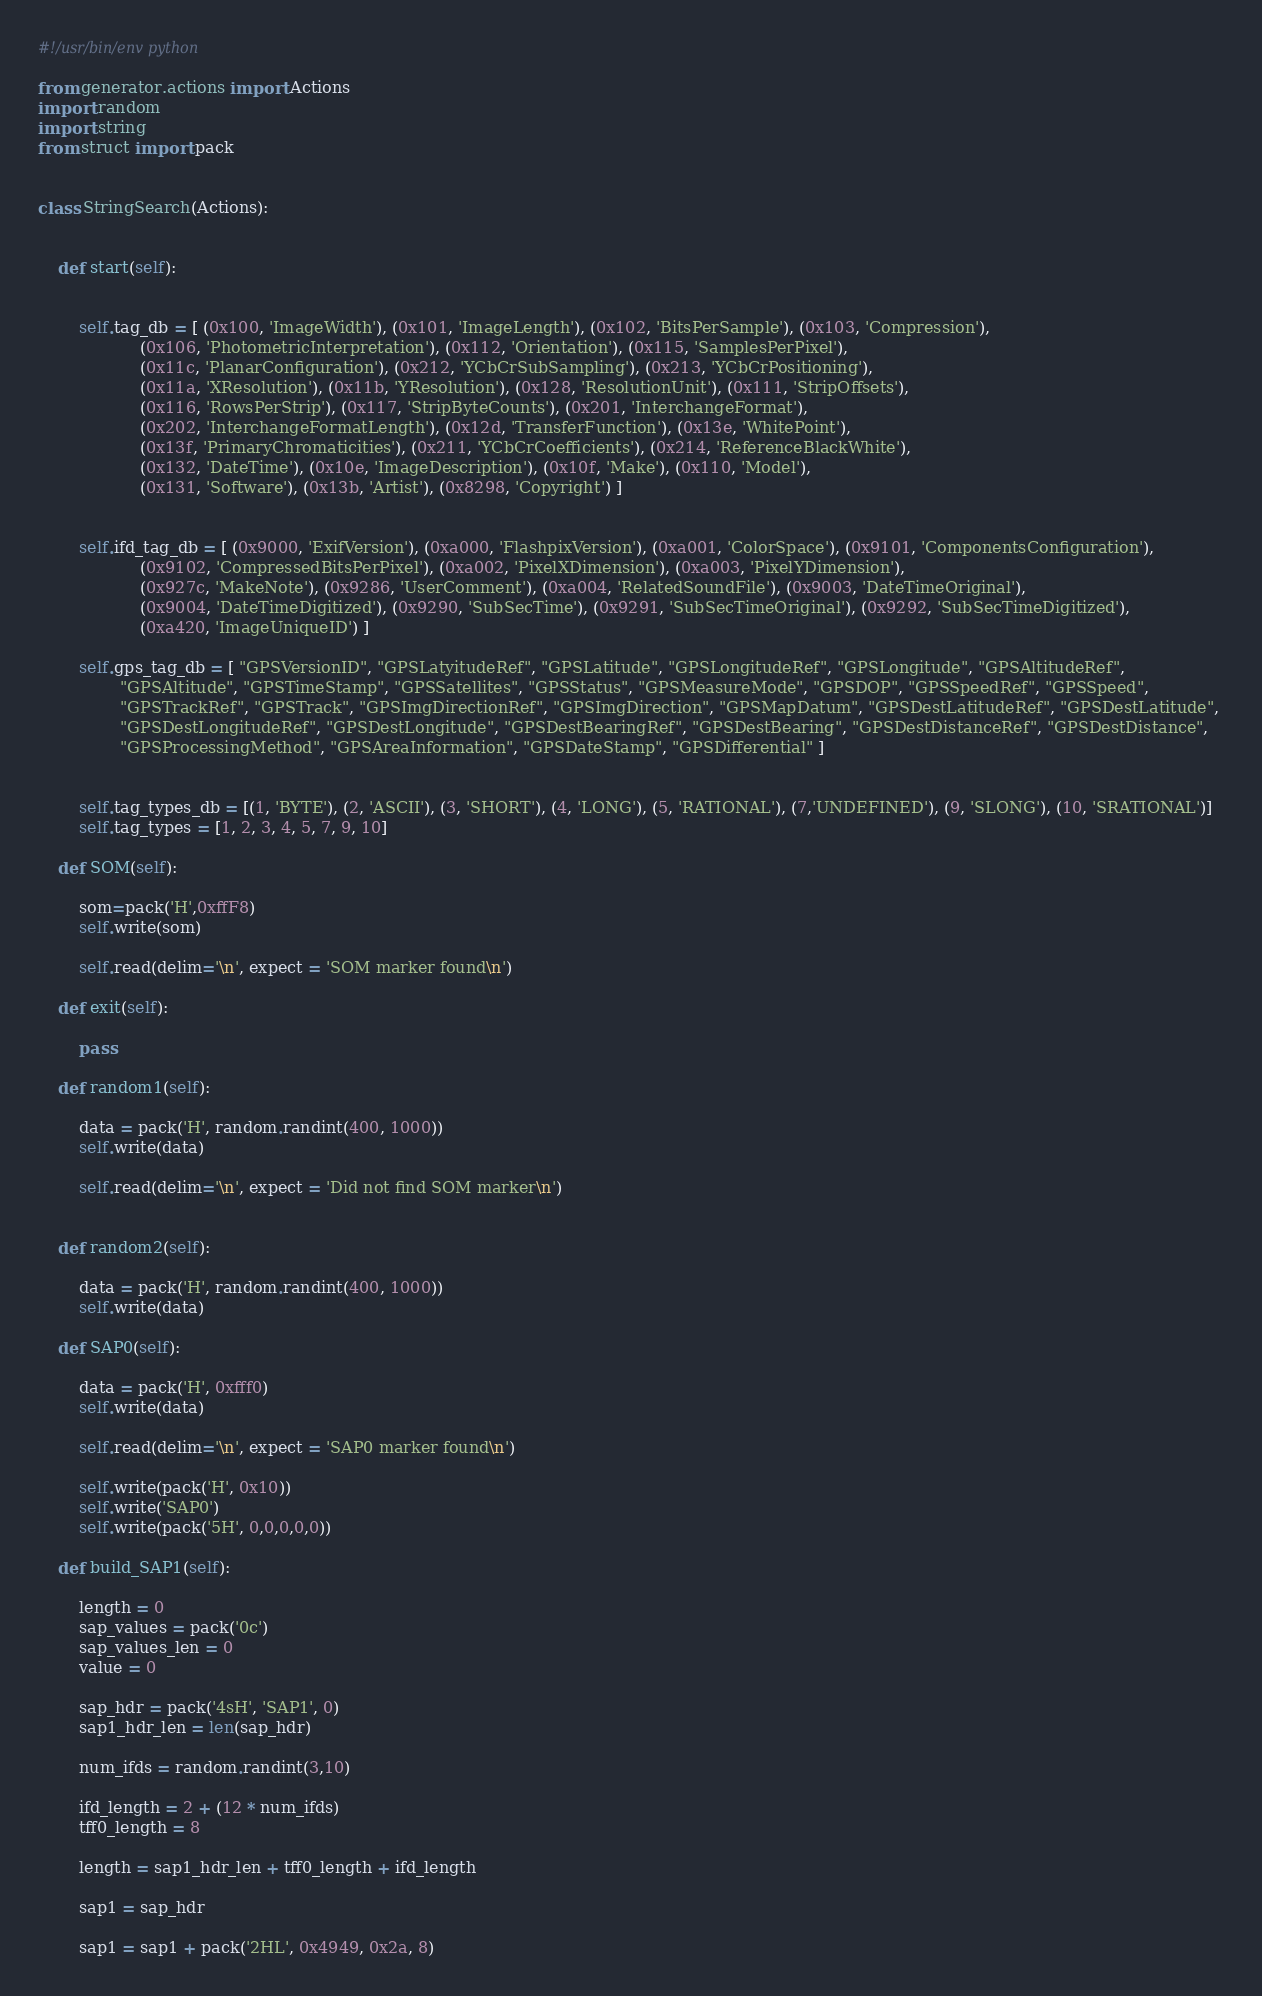<code> <loc_0><loc_0><loc_500><loc_500><_Python_>#!/usr/bin/env python

from generator.actions import Actions
import random
import string
from struct import pack


class StringSearch(Actions):


    def start(self):


        self.tag_db = [ (0x100, 'ImageWidth'), (0x101, 'ImageLength'), (0x102, 'BitsPerSample'), (0x103, 'Compression'),
                    (0x106, 'PhotometricInterpretation'), (0x112, 'Orientation'), (0x115, 'SamplesPerPixel'), 
                    (0x11c, 'PlanarConfiguration'), (0x212, 'YCbCrSubSampling'), (0x213, 'YCbCrPositioning'),
                    (0x11a, 'XResolution'), (0x11b, 'YResolution'), (0x128, 'ResolutionUnit'), (0x111, 'StripOffsets'),
                    (0x116, 'RowsPerStrip'), (0x117, 'StripByteCounts'), (0x201, 'InterchangeFormat'),
                    (0x202, 'InterchangeFormatLength'), (0x12d, 'TransferFunction'), (0x13e, 'WhitePoint'), 
                    (0x13f, 'PrimaryChromaticities'), (0x211, 'YCbCrCoefficients'), (0x214, 'ReferenceBlackWhite'),
                    (0x132, 'DateTime'), (0x10e, 'ImageDescription'), (0x10f, 'Make'), (0x110, 'Model'),
                    (0x131, 'Software'), (0x13b, 'Artist'), (0x8298, 'Copyright') ]


        self.ifd_tag_db = [ (0x9000, 'ExifVersion'), (0xa000, 'FlashpixVersion'), (0xa001, 'ColorSpace'), (0x9101, 'ComponentsConfiguration'),
                    (0x9102, 'CompressedBitsPerPixel'), (0xa002, 'PixelXDimension'), (0xa003, 'PixelYDimension'), 
                    (0x927c, 'MakeNote'), (0x9286, 'UserComment'), (0xa004, 'RelatedSoundFile'), (0x9003, 'DateTimeOriginal'),
                    (0x9004, 'DateTimeDigitized'), (0x9290, 'SubSecTime'), (0x9291, 'SubSecTimeOriginal'), (0x9292, 'SubSecTimeDigitized'),
                    (0xa420, 'ImageUniqueID') ]

        self.gps_tag_db = [ "GPSVersionID", "GPSLatyitudeRef", "GPSLatitude", "GPSLongitudeRef", "GPSLongitude", "GPSAltitudeRef", 
                "GPSAltitude", "GPSTimeStamp", "GPSSatellites", "GPSStatus", "GPSMeasureMode", "GPSDOP", "GPSSpeedRef", "GPSSpeed", 
                "GPSTrackRef", "GPSTrack", "GPSImgDirectionRef", "GPSImgDirection", "GPSMapDatum", "GPSDestLatitudeRef", "GPSDestLatitude", 
                "GPSDestLongitudeRef", "GPSDestLongitude", "GPSDestBearingRef", "GPSDestBearing", "GPSDestDistanceRef", "GPSDestDistance", 
                "GPSProcessingMethod", "GPSAreaInformation", "GPSDateStamp", "GPSDifferential" ]


        self.tag_types_db = [(1, 'BYTE'), (2, 'ASCII'), (3, 'SHORT'), (4, 'LONG'), (5, 'RATIONAL'), (7,'UNDEFINED'), (9, 'SLONG'), (10, 'SRATIONAL')]
        self.tag_types = [1, 2, 3, 4, 5, 7, 9, 10]

    def SOM(self):

        som=pack('H',0xffF8)
        self.write(som)

        self.read(delim='\n', expect = 'SOM marker found\n')

    def exit(self):

        pass

    def random1(self):

        data = pack('H', random.randint(400, 1000))
        self.write(data)

        self.read(delim='\n', expect = 'Did not find SOM marker\n')


    def random2(self):

        data = pack('H', random.randint(400, 1000))
        self.write(data)

    def SAP0(self):

        data = pack('H', 0xfff0)
        self.write(data)

        self.read(delim='\n', expect = 'SAP0 marker found\n')

        self.write(pack('H', 0x10))
        self.write('SAP0')
        self.write(pack('5H', 0,0,0,0,0))

    def build_SAP1(self):

        length = 0
        sap_values = pack('0c')
        sap_values_len = 0
        value = 0

        sap_hdr = pack('4sH', 'SAP1', 0)
        sap1_hdr_len = len(sap_hdr)

        num_ifds = random.randint(3,10)

        ifd_length = 2 + (12 * num_ifds)
        tff0_length = 8

        length = sap1_hdr_len + tff0_length + ifd_length

        sap1 = sap_hdr

        sap1 = sap1 + pack('2HL', 0x4949, 0x2a, 8)
</code> 